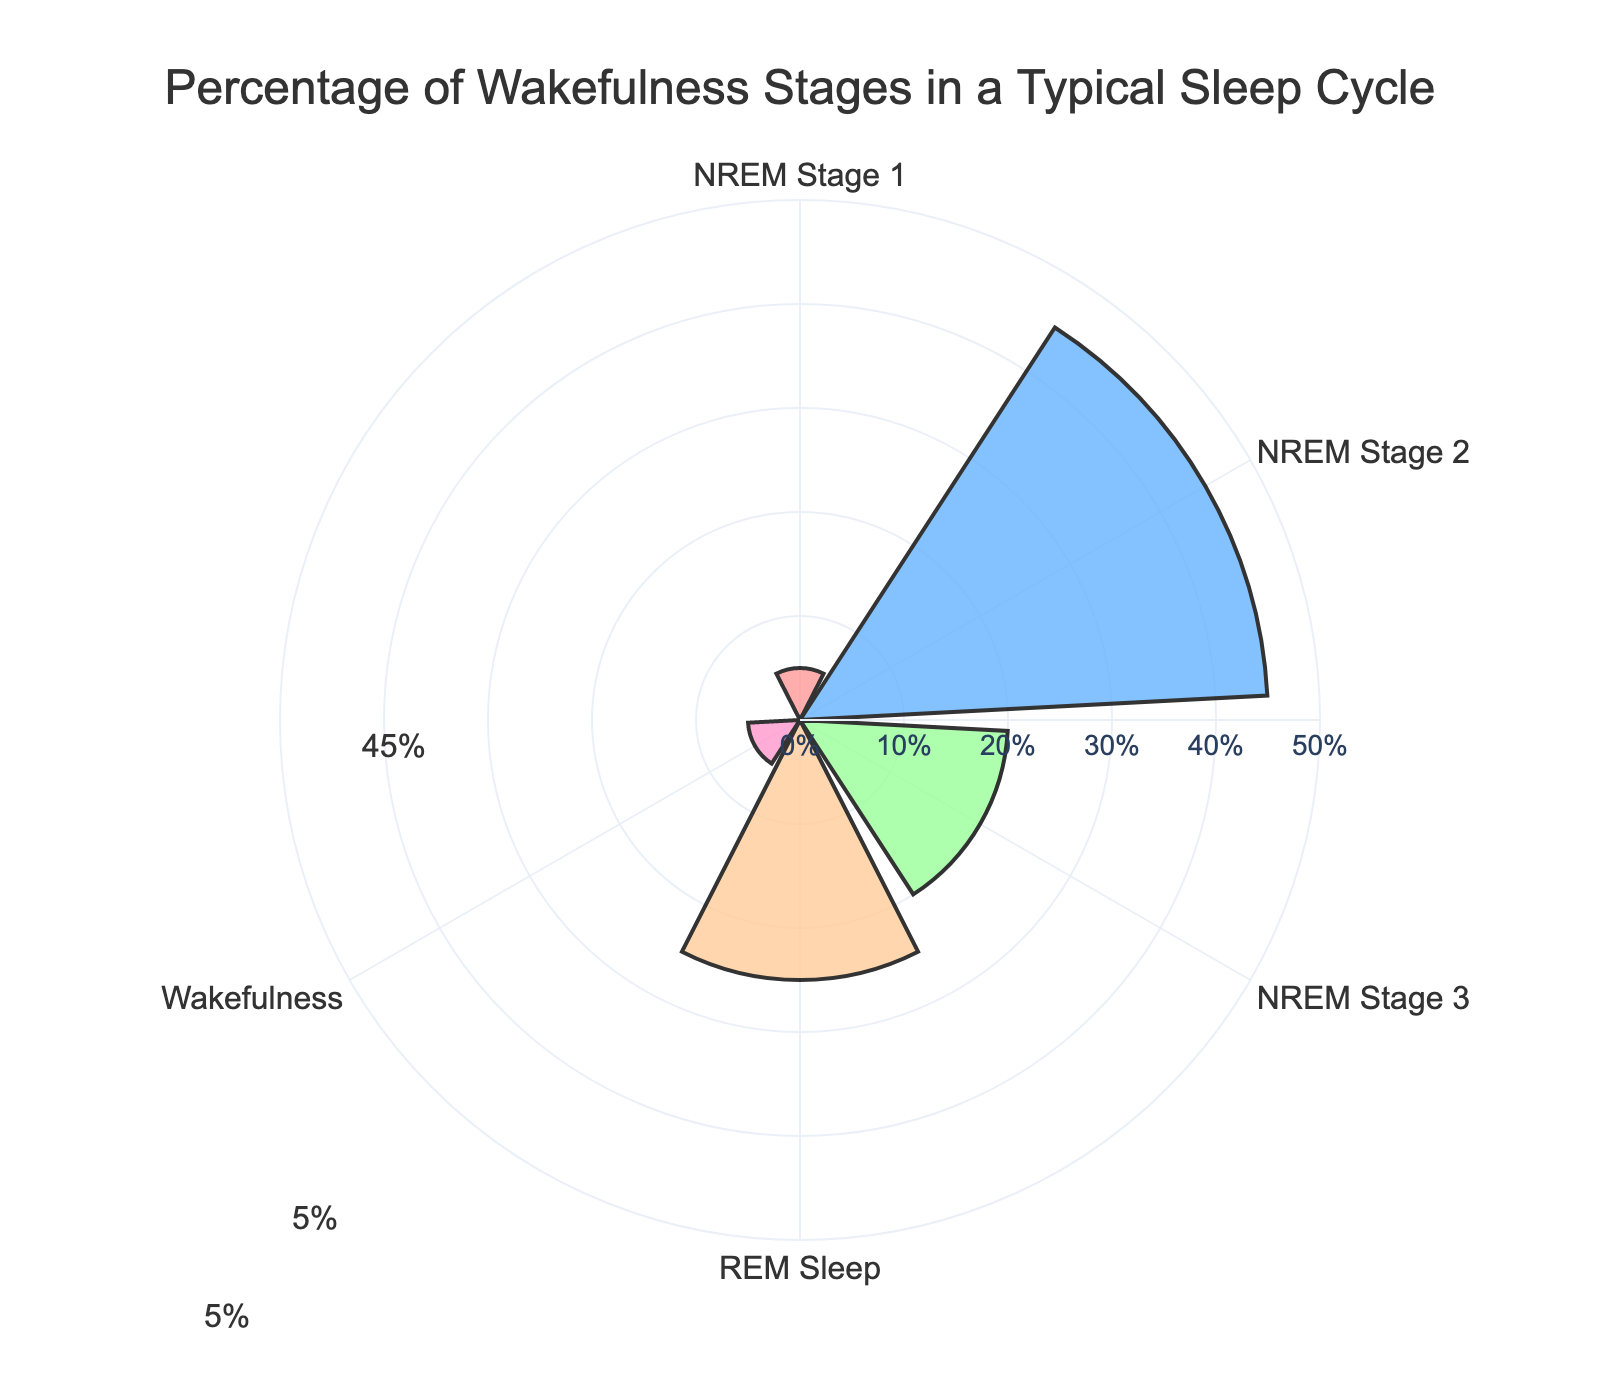What's the largest percentage slice in the rose chart? The chart shows various segments with their respective percentages. The slice representing NREM Stage 2 is the largest at 45%.
Answer: NREM Stage 2 Which two stages contribute to half of the sleep cycle? Adding up the percentages, NREM Stage 2 (45%) and REM Sleep (25%) give a total of 70%, which is more than half. However, the stages NREM Stage 1 (5%) and NREM Stage 3 (20%) together with Wakefulness (5%) add up to 30%, thus making two stages adding up to near half, are NREM Stage 2 (45%) and NREM Stage 3 (20%) totaling to 65%.
Answer: NREM Stage 2 and NREM Stage 3 What is the total percentage of NREM stages in the sleep cycle? The total percentage of NREM stages is found by adding NREM Stage 1 (5%), NREM Stage 2 (45%), and NREM Stage 3 (20%). Thus, 5% + 45% + 20% = 70%.
Answer: 70% Which stage has the smallest percentage in the rose chart? By examining the slices, the Wakefulness and NREM Stage 1 each have the smallest percentage, both at 5%.
Answer: Wakefulness and NREM Stage 1 How does the percentage of REM Sleep compare to NREM Stage 3? REM Sleep accounts for 25%, while NREM Stage 3 accounts for 20%. Thus, REM Sleep is higher by 5%.
Answer: REM Sleep is higher What is the sum of the percentages of REM Sleep and Wakefulness? To find this, we add REM Sleep (25%) and Wakefulness (5%). Therefore, 25% + 5% = 30%.
Answer: 30% If we remove the Wakefulness percentage, what percentage do the remaining stages represent? The total percentage is 100%. Subtracting the Wakefulness percentage (5%), the remaining stages represent 100% - 5% = 95%.
Answer: 95% Is the percentage of NREM Stage 2 more than twice the percentage of REM Sleep? NREM Stage 2 is 45%, and REM Sleep is 25%. Twice the percentage of REM Sleep is 25% * 2 = 50%. Since 45% is less than 50%, NREM Stage 2 is not more than twice the percentage of REM Sleep.
Answer: No What is the average percentage of NREM stages? To find the average, sum the percentages of NREM Stage 1 (5%), NREM Stage 2 (45%), and NREM Stage 3 (20%), which totals 70%. Dividing by the number of stages (3), the average is 70% / 3 = 23.33%.
Answer: 23.33% If you combine NREM Stage 1 and Wakefulness, does their combined percentage exceed NREM Stage 3? Adding NREM Stage 1 (5%) and Wakefulness (5%) gives 10%. Comparing this to NREM Stage 3 (20%), 10% is less than 20%.
Answer: No 